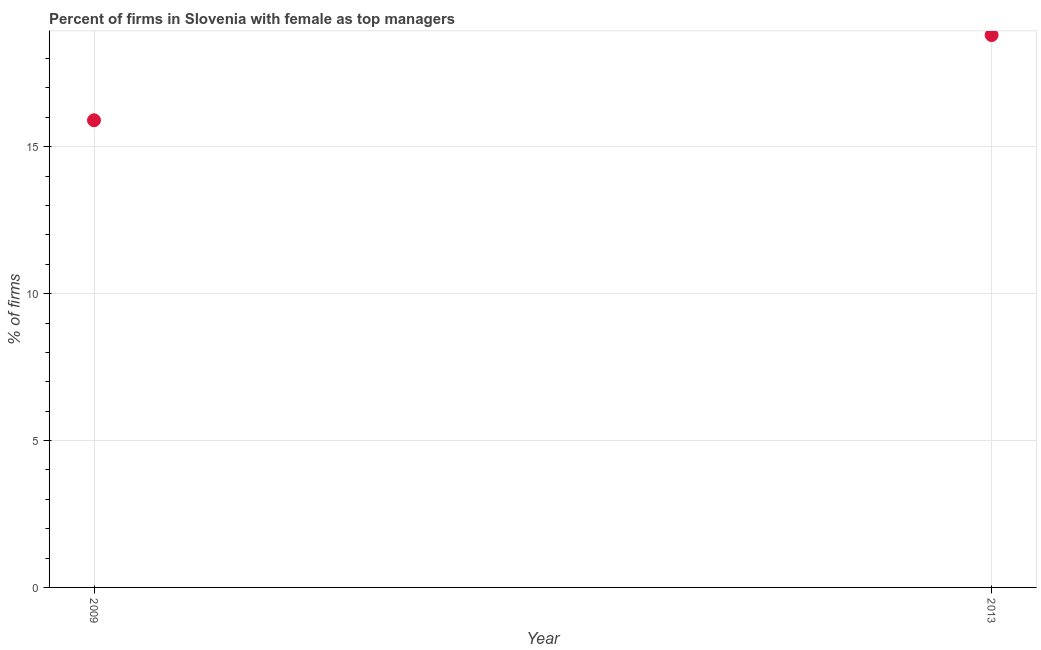What is the percentage of firms with female as top manager in 2009?
Provide a succinct answer. 15.9. Across all years, what is the maximum percentage of firms with female as top manager?
Provide a succinct answer. 18.8. In which year was the percentage of firms with female as top manager maximum?
Give a very brief answer. 2013. What is the sum of the percentage of firms with female as top manager?
Ensure brevity in your answer.  34.7. What is the difference between the percentage of firms with female as top manager in 2009 and 2013?
Offer a terse response. -2.9. What is the average percentage of firms with female as top manager per year?
Offer a terse response. 17.35. What is the median percentage of firms with female as top manager?
Keep it short and to the point. 17.35. Do a majority of the years between 2009 and 2013 (inclusive) have percentage of firms with female as top manager greater than 11 %?
Your answer should be very brief. Yes. What is the ratio of the percentage of firms with female as top manager in 2009 to that in 2013?
Offer a very short reply. 0.85. In how many years, is the percentage of firms with female as top manager greater than the average percentage of firms with female as top manager taken over all years?
Give a very brief answer. 1. Does the percentage of firms with female as top manager monotonically increase over the years?
Provide a succinct answer. Yes. How many dotlines are there?
Your answer should be compact. 1. How many years are there in the graph?
Keep it short and to the point. 2. What is the difference between two consecutive major ticks on the Y-axis?
Your answer should be very brief. 5. Are the values on the major ticks of Y-axis written in scientific E-notation?
Make the answer very short. No. Does the graph contain grids?
Offer a very short reply. Yes. What is the title of the graph?
Give a very brief answer. Percent of firms in Slovenia with female as top managers. What is the label or title of the X-axis?
Offer a very short reply. Year. What is the label or title of the Y-axis?
Your answer should be compact. % of firms. What is the % of firms in 2013?
Your answer should be very brief. 18.8. What is the ratio of the % of firms in 2009 to that in 2013?
Offer a very short reply. 0.85. 